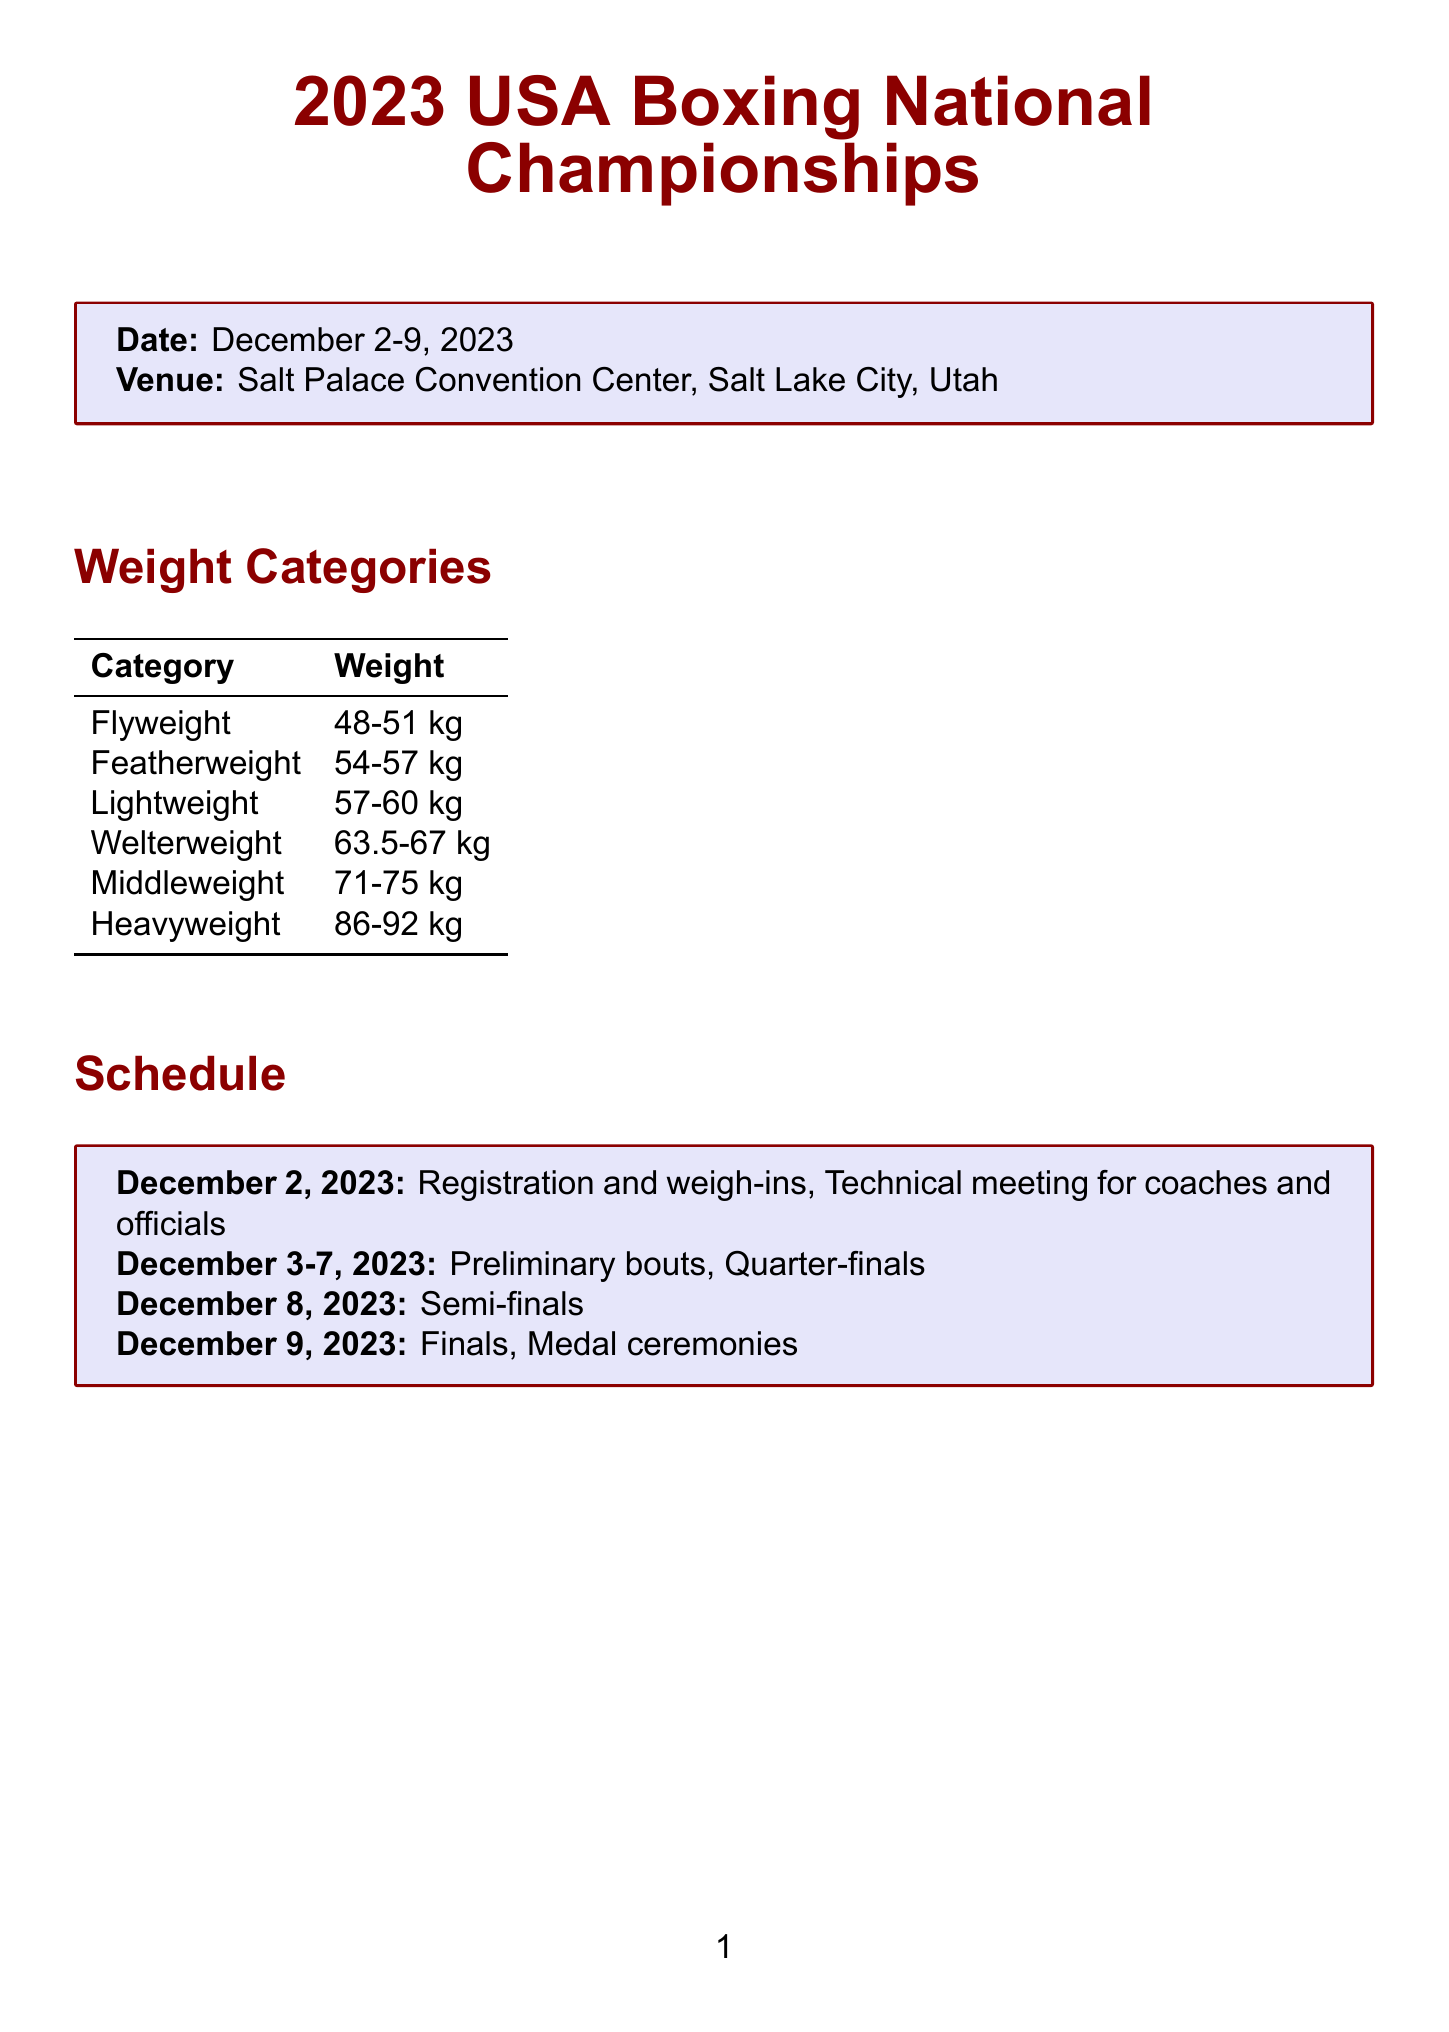What is the name of the tournament? The name of the tournament is mentioned at the top of the document.
Answer: 2023 USA Boxing National Championships In which city is the tournament being held? The city is specified in the venue section of the document.
Answer: Salt Lake City What is the date range of the tournament? The date range is stated prominently in the document.
Answer: December 2-9, 2023 Which weight category includes boxers weighing 57-60 kg? The weight categories table shows which category corresponds to this weight range.
Answer: Lightweight Who is the presenter of the aggressive boxing seminar? The presenter is listed in the special events section of the document.
Answer: Mike Tyson What is the registration deadline? The registration deadline is clearly outlined in the important information section.
Answer: November 15, 2023 What event occurs on December 8, 2023? The specific event is detailed in the schedule of the document.
Answer: Semi-finals Who are the guests at the meet and greet event? The names of the guests are included in the special events section of the document.
Answer: Claressa Shields, Richard Torrez Jr What is required for all bouts according to the important notes? The document explicitly states the requirements in the important notes section.
Answer: Headgear is mandatory for all bouts 